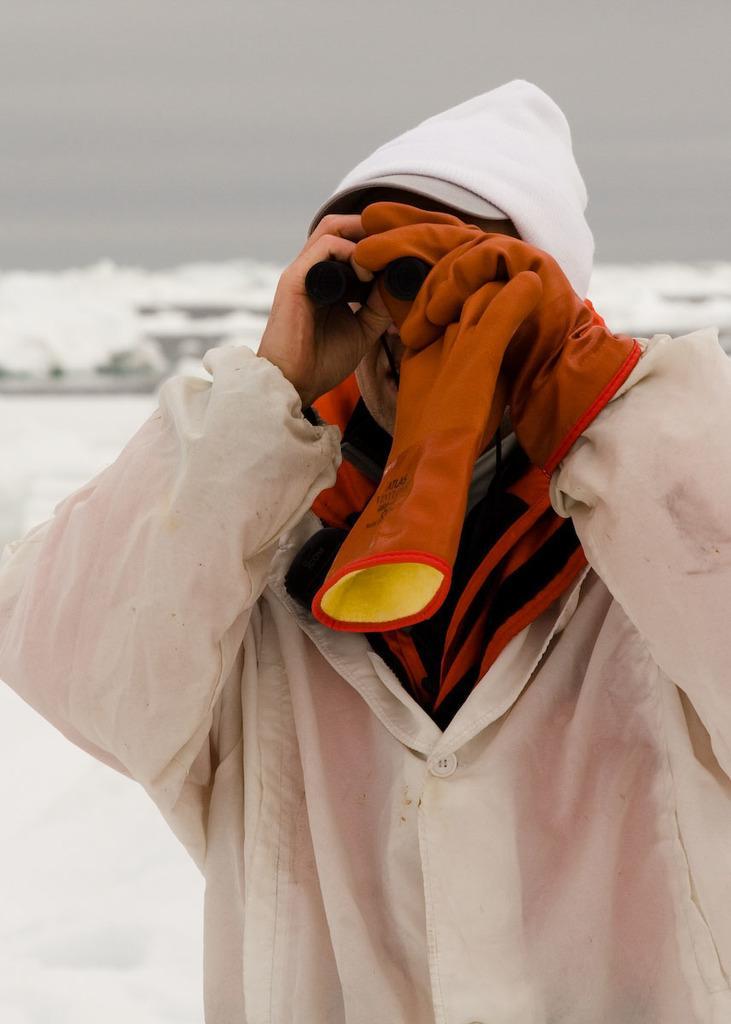Could you give a brief overview of what you see in this image? In this picture there is a person with white coat is standing and holding the binoculars. At the back it looks like snow. At the top there is sky. 